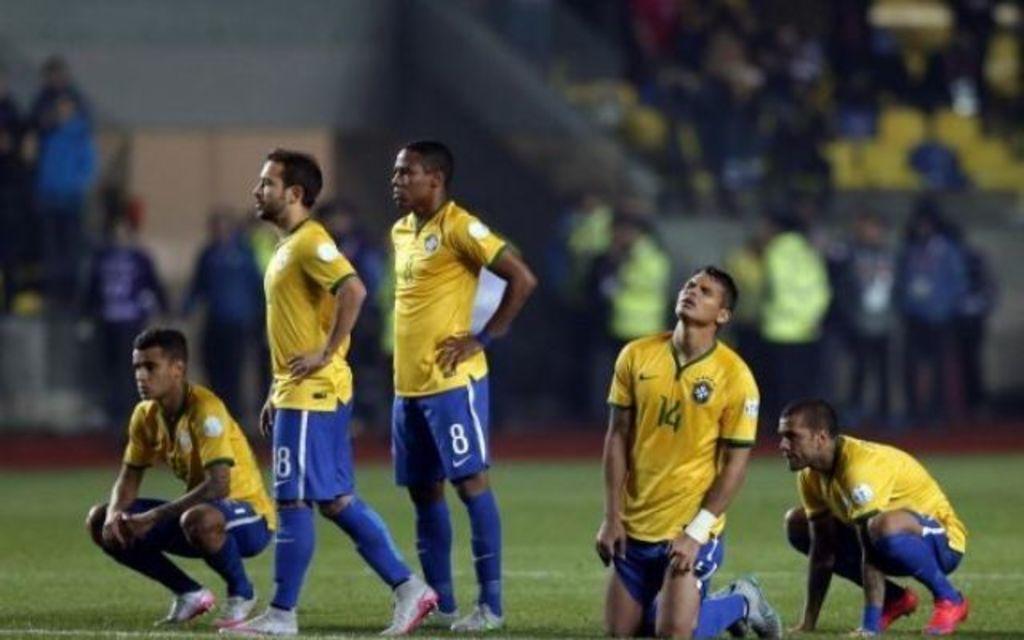Please provide a concise description of this image. In this image in the front there are persons standing. In the center there is grass on the ground. In the background there are persons and it seems to be blurry. In the front there are persons squatting and there is a person kneeling on the ground. 